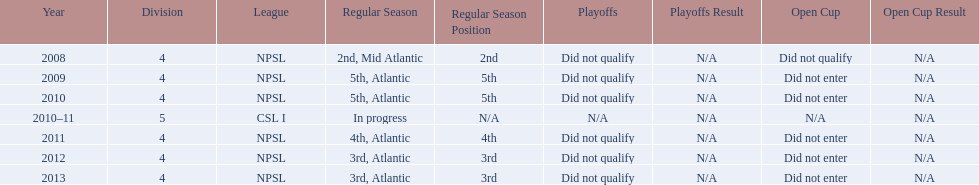What are the names of the leagues? NPSL, CSL I. Which league other than npsl did ny soccer team play under? CSL I. 